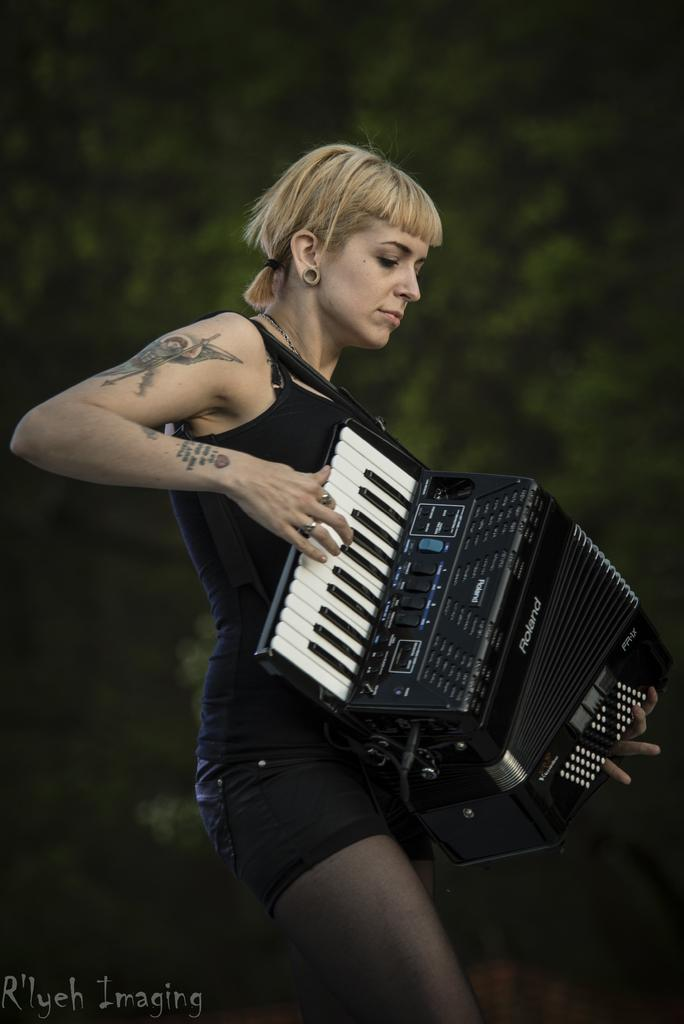What is the main subject of the image? The main subject of the image is a woman. What is the woman wearing in the image? The woman is wearing a black dress in the image. What is the woman doing in the image? The woman is playing a piano harmonium in the image. What can be seen in the background of the image? There is a tree in the background of the image. What is the increase in the number of railway tracks in the image? There is no railway or any reference to an increase in the image; it features a woman playing a piano harmonium. What causes the burst of the balloon in the image? There is no balloon or any indication of a burst in the image. 